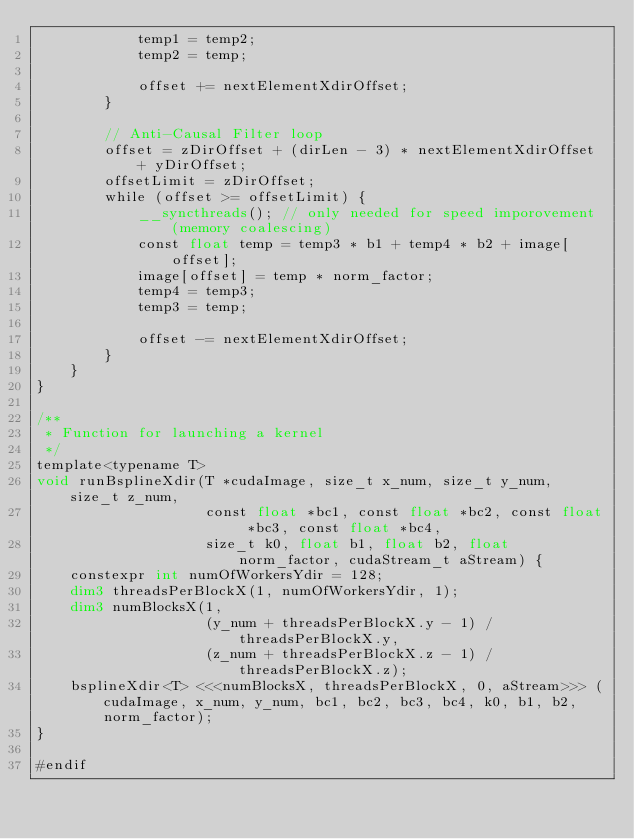<code> <loc_0><loc_0><loc_500><loc_500><_Cuda_>            temp1 = temp2;
            temp2 = temp;

            offset += nextElementXdirOffset;
        }

        // Anti-Causal Filter loop
        offset = zDirOffset + (dirLen - 3) * nextElementXdirOffset + yDirOffset;
        offsetLimit = zDirOffset;
        while (offset >= offsetLimit) {
            __syncthreads(); // only needed for speed imporovement (memory coalescing)
            const float temp = temp3 * b1 + temp4 * b2 + image[offset];
            image[offset] = temp * norm_factor;
            temp4 = temp3;
            temp3 = temp;

            offset -= nextElementXdirOffset;
        }
    }
}

/**
 * Function for launching a kernel
 */
template<typename T>
void runBsplineXdir(T *cudaImage, size_t x_num, size_t y_num, size_t z_num,
                    const float *bc1, const float *bc2, const float *bc3, const float *bc4,
                    size_t k0, float b1, float b2, float norm_factor, cudaStream_t aStream) {
    constexpr int numOfWorkersYdir = 128;
    dim3 threadsPerBlockX(1, numOfWorkersYdir, 1);
    dim3 numBlocksX(1,
                    (y_num + threadsPerBlockX.y - 1) / threadsPerBlockX.y,
                    (z_num + threadsPerBlockX.z - 1) / threadsPerBlockX.z);
    bsplineXdir<T> <<<numBlocksX, threadsPerBlockX, 0, aStream>>> (cudaImage, x_num, y_num, bc1, bc2, bc3, bc4, k0, b1, b2, norm_factor);
}

#endif
</code> 